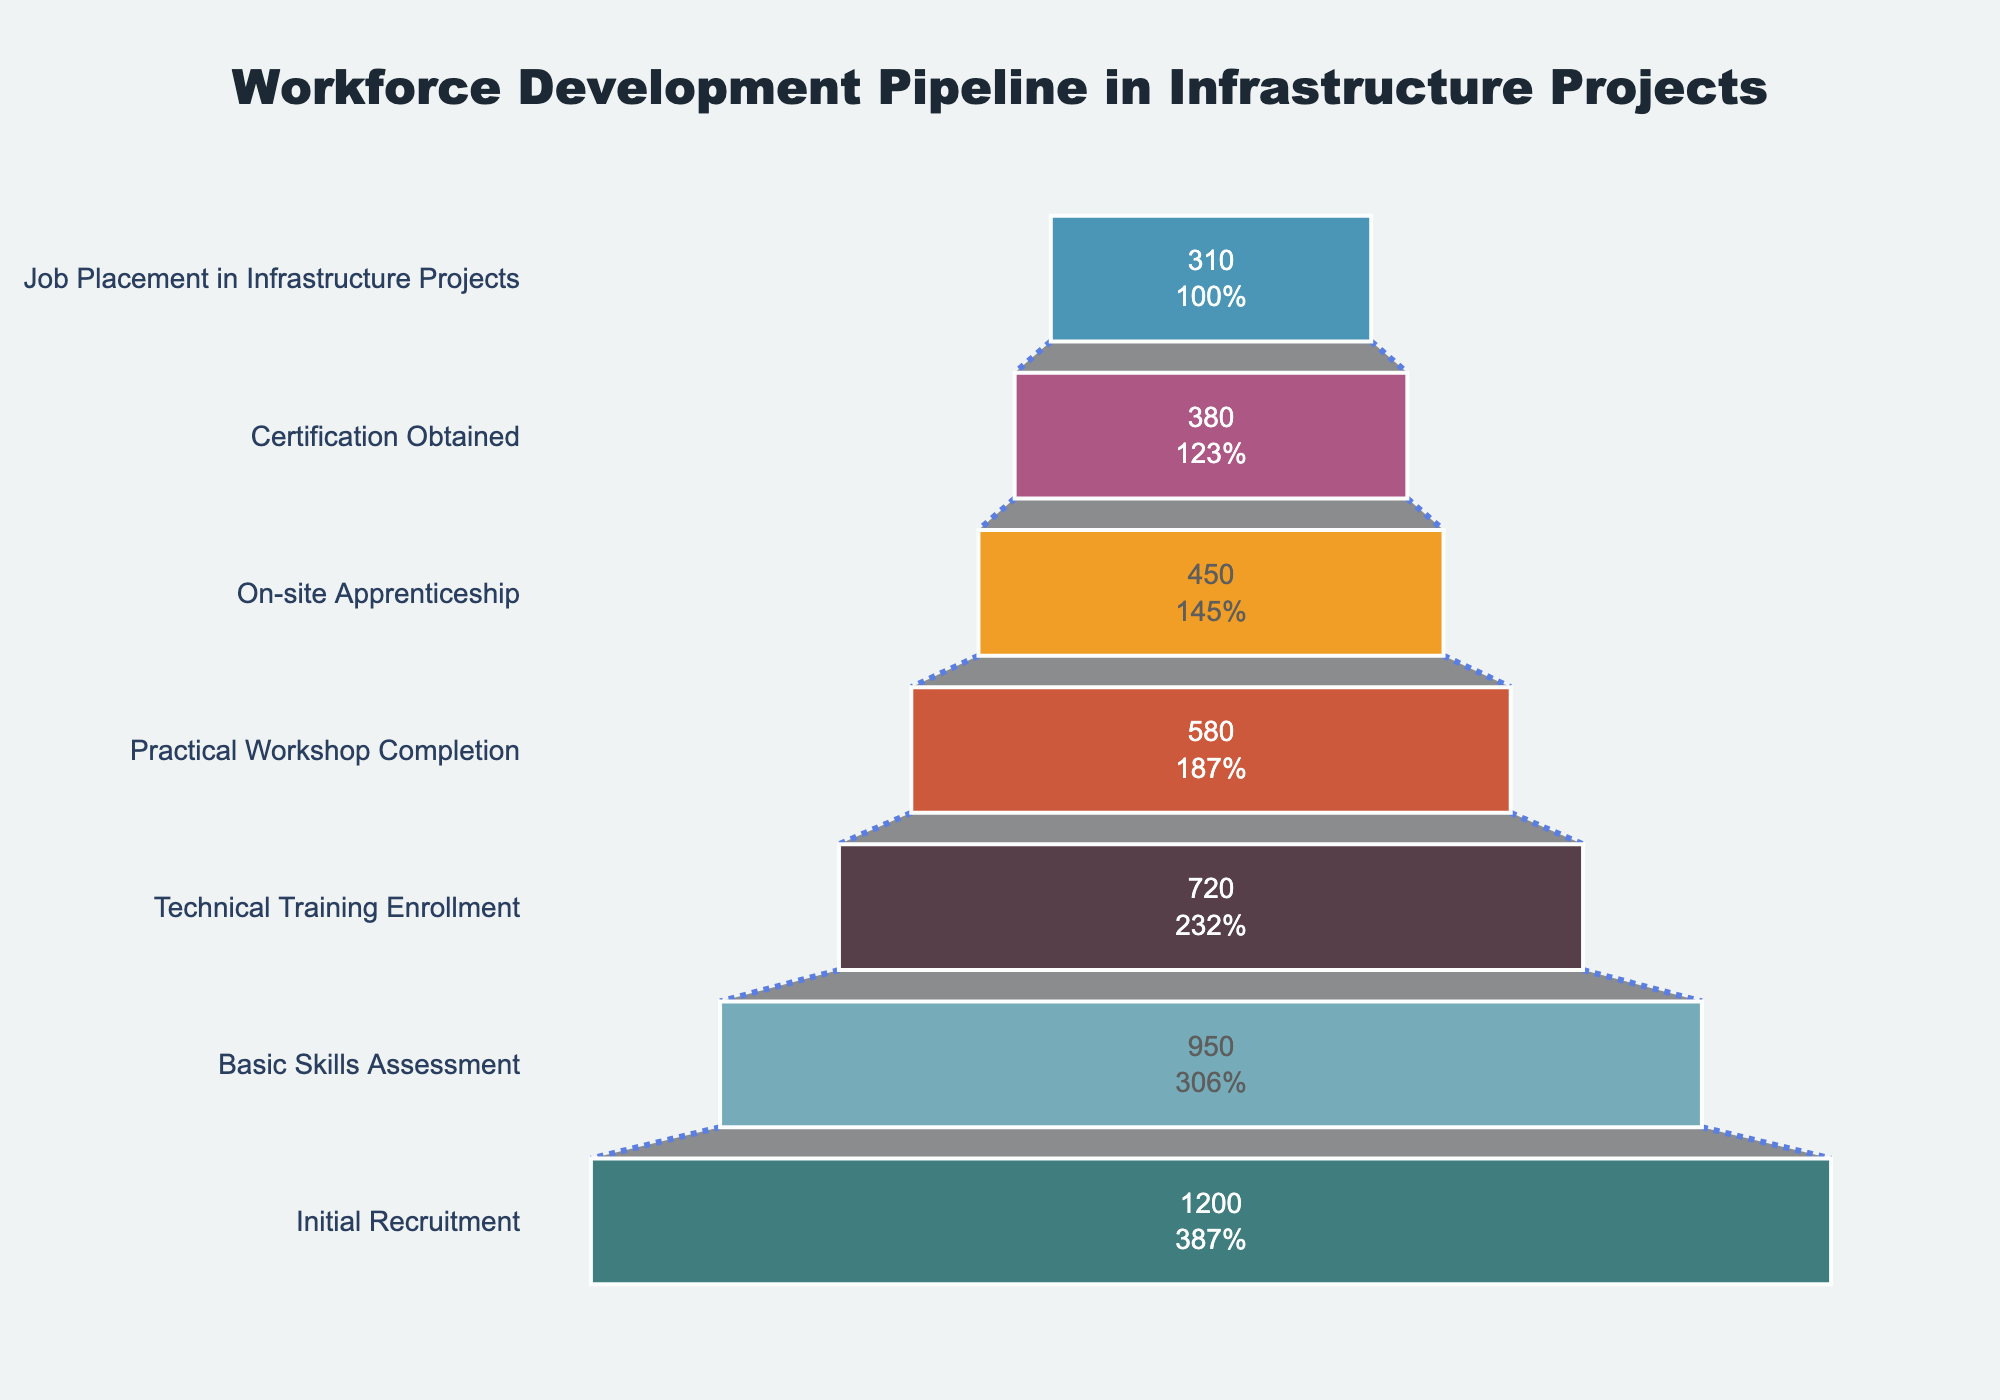What's the title of the figure? The title is written at the top of the figure. It reads: "Workforce Development Pipeline in Infrastructure Projects".
Answer: Workforce Development Pipeline in Infrastructure Projects How many stages are there in the funnel chart? Each stage corresponds to a distinct step in the skill development program, visually represented on the y-axis. By counting them, we get seven stages.
Answer: Seven What is the percentage of participants who enrolled in the Technical Training compared to the initial recruitment? Look at the funnel segment labeled 'Technical Training Enrollment'. The percentage is displayed inside each segment. The value is 60% of the initial 1200 participants.
Answer: 60% How many participants failed to complete the Practical Workshop after enrolling in technical training? The difference between 'Technical Training Enrollment' (720) and 'Practical Workshop Completion' (580) gives the number of participants who didn't complete it. 720 - 580 = 140.
Answer: 140 Which stage has the highest drop-off rate in terms of absolute participant numbers? Compare the differences in participant numbers between consecutive stages. The largest drop is from 'Initial Recruitment' (1200) to 'Basic Skills Assessment' (950), which is 250 participants.
Answer: Basic Skills Assessment What is the difference in participant numbers between the Practical Workshop Completion stage and the Job Placement in Infrastructure Projects stage? Subtract the number of participants in 'Job Placement in Infrastructure Projects' (310) from those in 'Practical Workshop Completion' (580). 580 - 310 = 270.
Answer: 270 Which stages have a participant drop of exactly 70? Compare the participant numbers between consecutive stages. The drop between 'On-site Apprenticeship' (450) and 'Certification Obtained' (380) is exactly 70.
Answer: 'On-site Apprenticeship' to 'Certification Obtained' What is the percentage of participants who obtained certification out of those who completed the Practical Workshop? The percentage is calculated by comparing the participants at 'Certification Obtained' (380) to those at 'Practical Workshop Completion' (580). (380/580) * 100 ≈ 65.5%.
Answer: 65.5% Which stage marks the lowest number of participants in the progression of skill development? The stage with the smallest number of participants is the last one in the funnel. 'Job Placement in Infrastructure Projects' has 310 participants.
Answer: Job Placement in Infrastructure Projects 